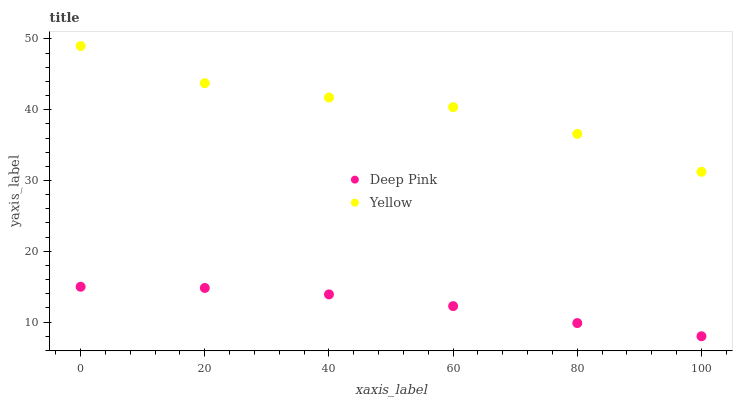Does Deep Pink have the minimum area under the curve?
Answer yes or no. Yes. Does Yellow have the maximum area under the curve?
Answer yes or no. Yes. Does Yellow have the minimum area under the curve?
Answer yes or no. No. Is Deep Pink the smoothest?
Answer yes or no. Yes. Is Yellow the roughest?
Answer yes or no. Yes. Is Yellow the smoothest?
Answer yes or no. No. Does Deep Pink have the lowest value?
Answer yes or no. Yes. Does Yellow have the lowest value?
Answer yes or no. No. Does Yellow have the highest value?
Answer yes or no. Yes. Is Deep Pink less than Yellow?
Answer yes or no. Yes. Is Yellow greater than Deep Pink?
Answer yes or no. Yes. Does Deep Pink intersect Yellow?
Answer yes or no. No. 